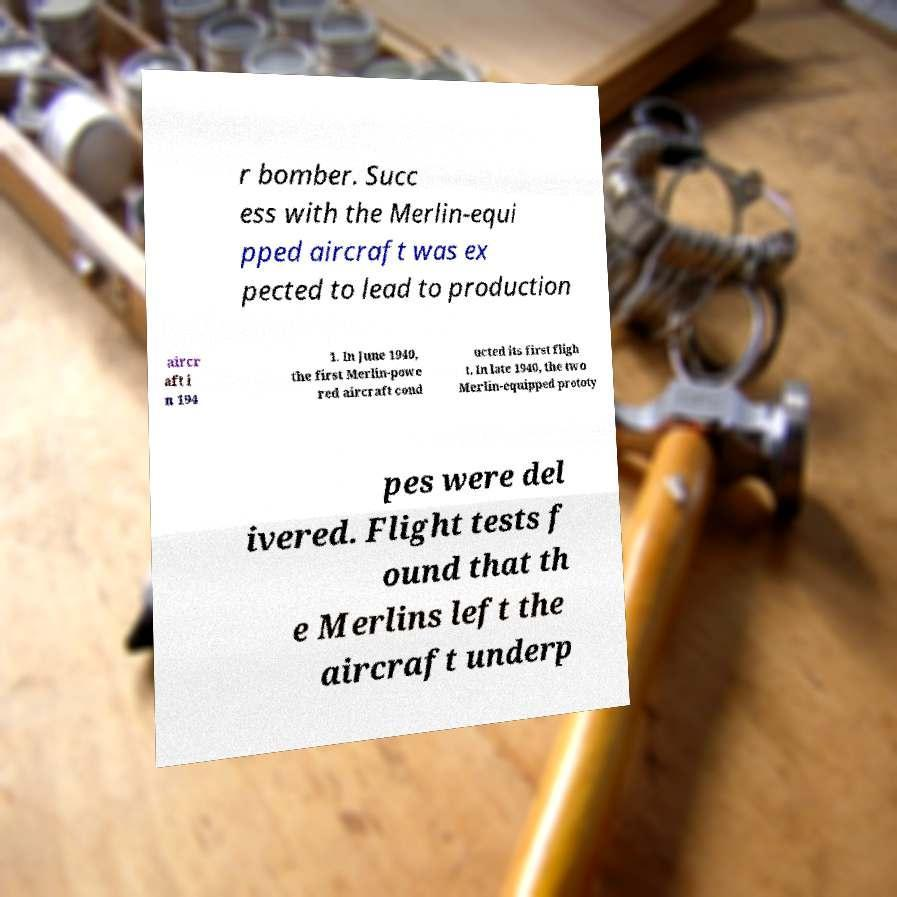Please read and relay the text visible in this image. What does it say? r bomber. Succ ess with the Merlin-equi pped aircraft was ex pected to lead to production aircr aft i n 194 1. In June 1940, the first Merlin-powe red aircraft cond ucted its first fligh t. In late 1940, the two Merlin-equipped prototy pes were del ivered. Flight tests f ound that th e Merlins left the aircraft underp 